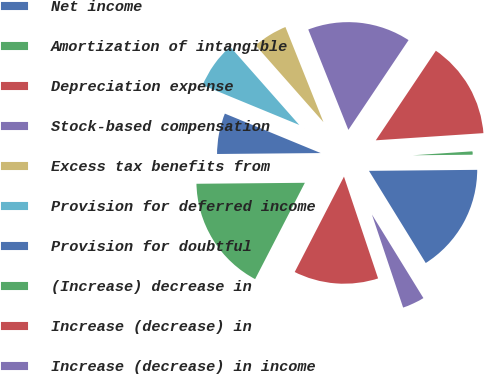Convert chart to OTSL. <chart><loc_0><loc_0><loc_500><loc_500><pie_chart><fcel>Net income<fcel>Amortization of intangible<fcel>Depreciation expense<fcel>Stock-based compensation<fcel>Excess tax benefits from<fcel>Provision for deferred income<fcel>Provision for doubtful<fcel>(Increase) decrease in<fcel>Increase (decrease) in<fcel>Increase (decrease) in income<nl><fcel>16.36%<fcel>0.91%<fcel>14.54%<fcel>15.45%<fcel>5.46%<fcel>7.27%<fcel>6.36%<fcel>17.27%<fcel>12.73%<fcel>3.64%<nl></chart> 